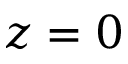Convert formula to latex. <formula><loc_0><loc_0><loc_500><loc_500>z = 0</formula> 